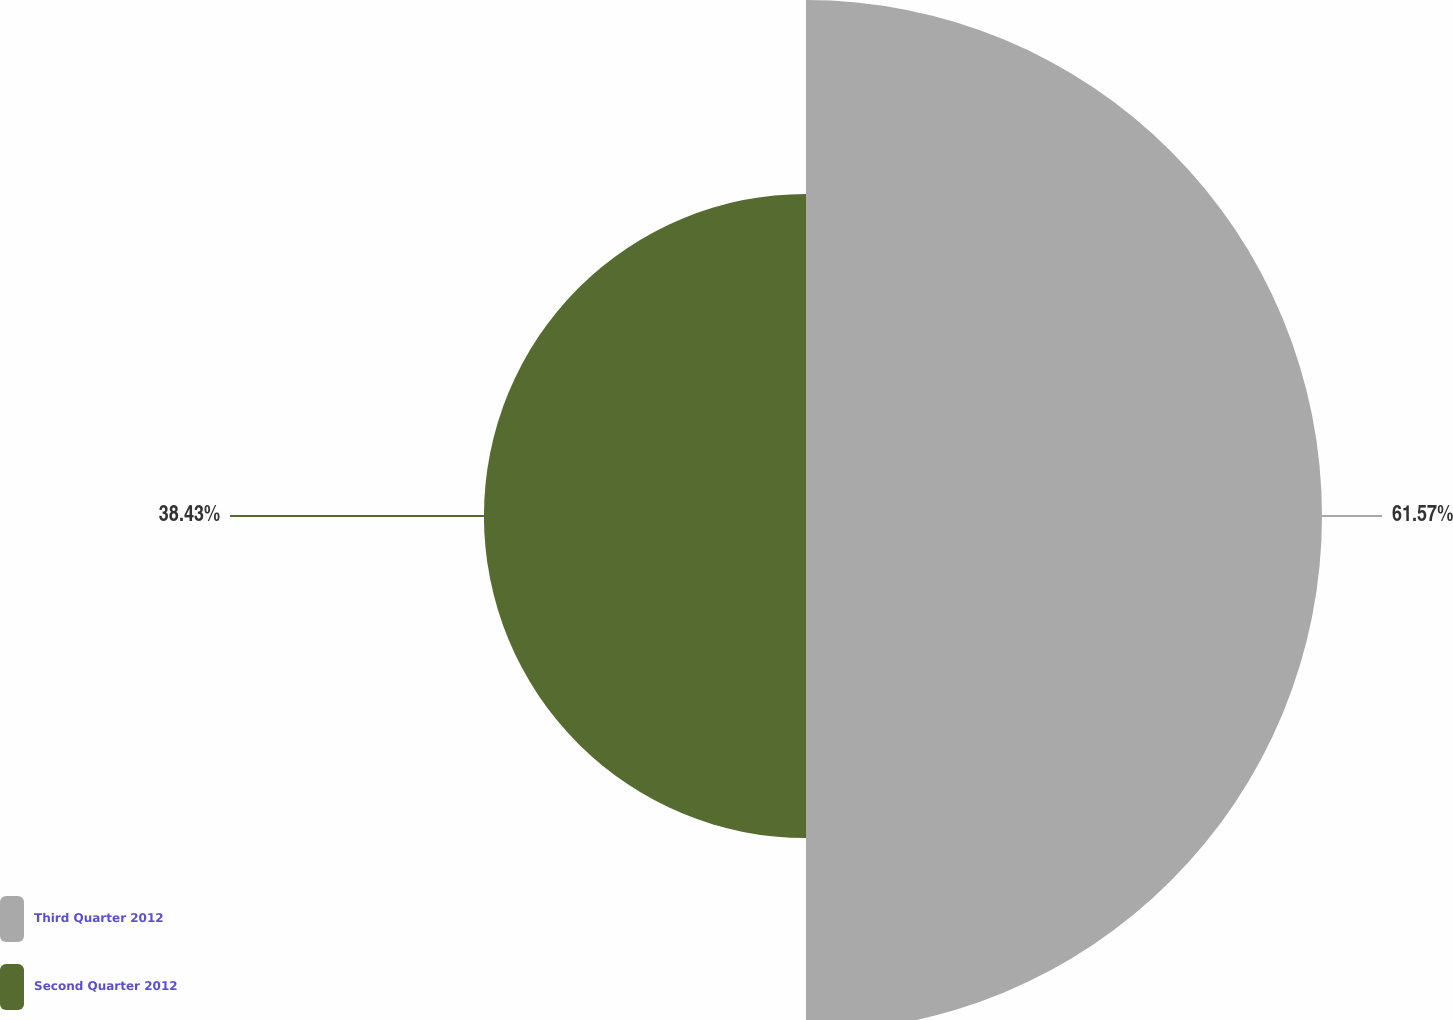Convert chart. <chart><loc_0><loc_0><loc_500><loc_500><pie_chart><fcel>Third Quarter 2012<fcel>Second Quarter 2012<nl><fcel>61.57%<fcel>38.43%<nl></chart> 